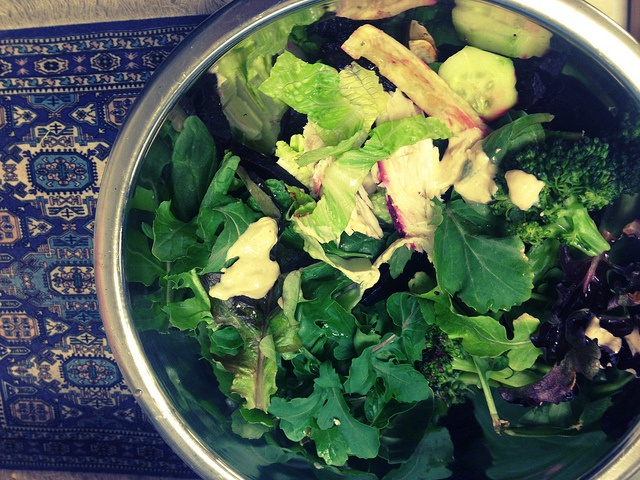Describe the objects in this image and their specific colors. I can see bowl in black, tan, darkgreen, khaki, and gray tones, broccoli in tan, black, darkgreen, green, and khaki tones, and broccoli in tan, black, darkgreen, and green tones in this image. 